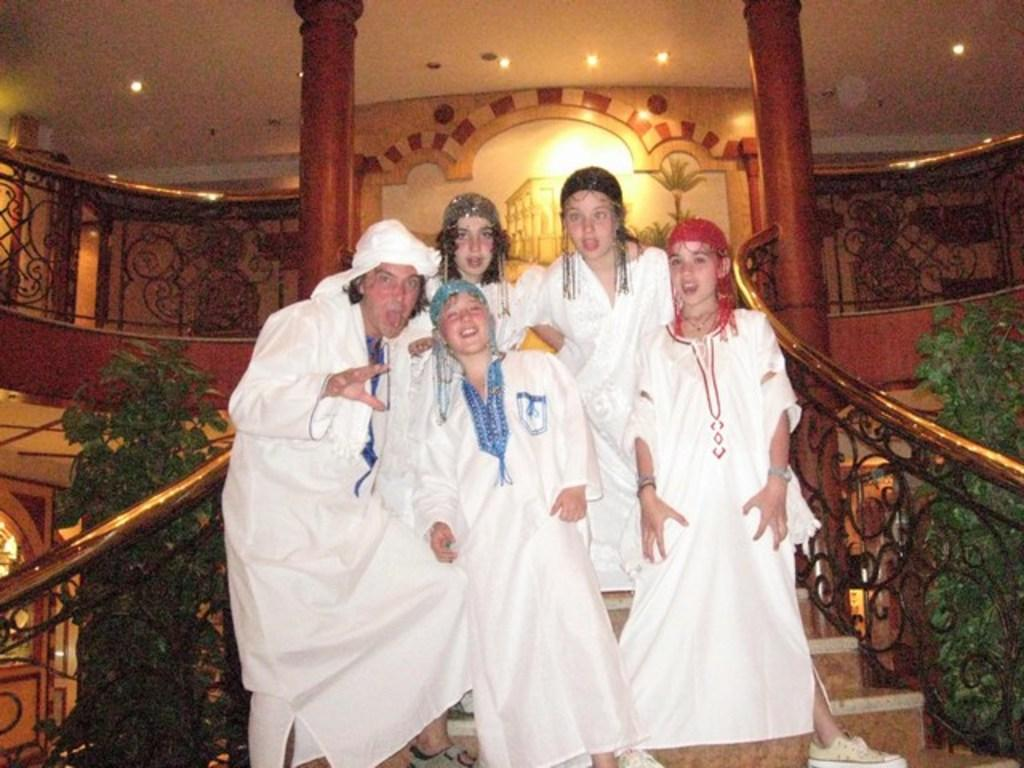How many people are standing on the stairs in the image? A: There are five persons standing on the stairs in the image. What other objects can be seen in the image besides the people on the stairs? There are house plants, lights, and iron grilles in the image. What type of frame is being used to cook the food in the image? There is no frame or cooking activity present in the image. 